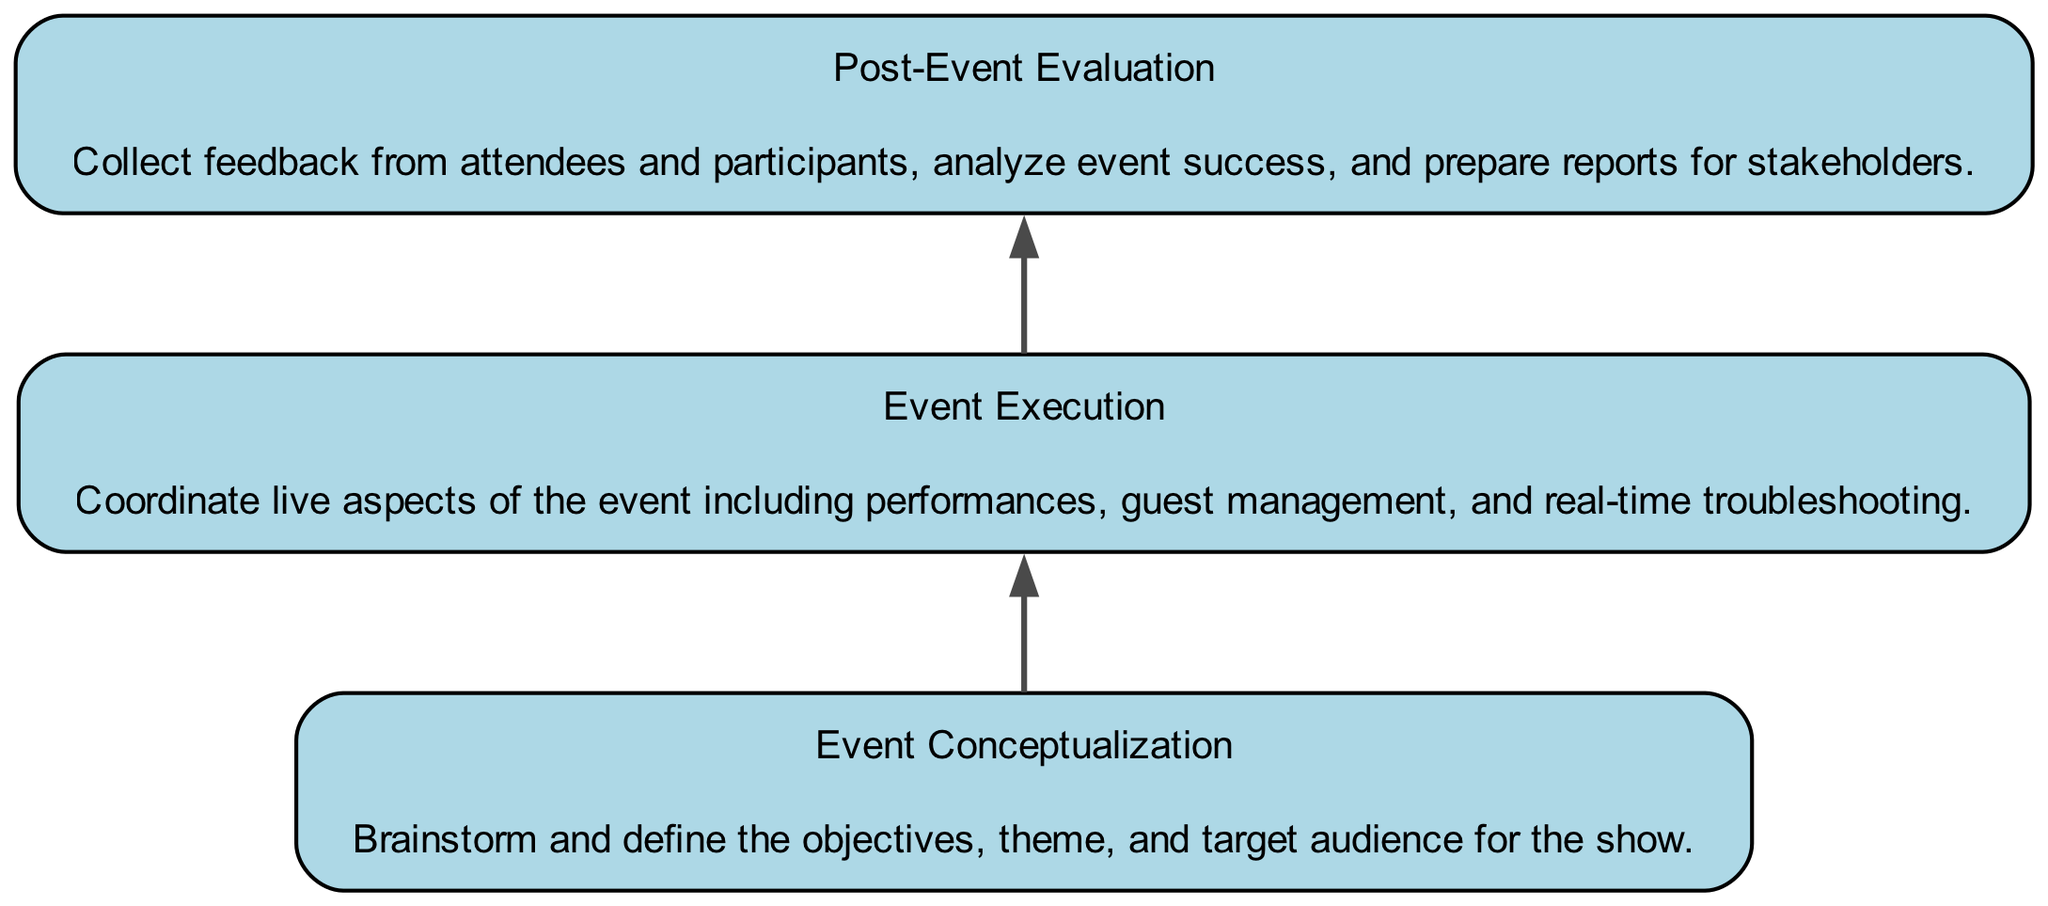What is the first element in the flow chart? The first element at the bottom of the flow chart is "Event Conceptualization." This is the starting point of the planning process.
Answer: Event Conceptualization How many total elements are there in the flow chart? The flow chart includes 9 elements, starting from "Event Conceptualization" at the bottom and ending with "Post-Event Evaluation" at the top.
Answer: 9 What comes directly after "Venue Selection"? After "Venue Selection," the next element is "Logistics Management." It follows in the flow of the planning and execution process.
Answer: Logistics Management Which element is at the top of the flow chart? The top element in the flow chart is "Post-Event Evaluation." This indicates the evaluation phase after the event execution.
Answer: Post-Event Evaluation Which two elements are connected to "Marketing and Promotion"? "Marketing and Promotion" is connected to "Budget Planning" above it and to "Ticketing and Registration" directly above it in the flow.
Answer: Budget Planning and Ticketing and Registration What is the purpose of "Rehearsals and Sound Check"? The purpose of "Rehearsals and Sound Check" is to ensure that performers are prepared and technical aspects are working smoothly before the event.
Answer: Ensure technical readiness How many edges are there in the diagram? There are 8 edges in the diagram, connecting each of the 9 elements in sequence from bottom to top.
Answer: 8 Which element is the direct predecessor of "Event Execution"? The direct predecessor of "Event Execution" is "Rehearsals and Sound Check." This shows the sequence in preparation for the live event.
Answer: Rehearsals and Sound Check What does "Ticketing and Registration" involve? "Ticketing and Registration" involves setting up platforms or forms for attendees, managing lists, and providing support, crucial for the event's organization.
Answer: Managing attendee lists and support 